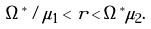<formula> <loc_0><loc_0><loc_500><loc_500>\Omega ^ { * } / \mu _ { 1 } < r < \Omega ^ { * } \mu _ { 2 } .</formula> 